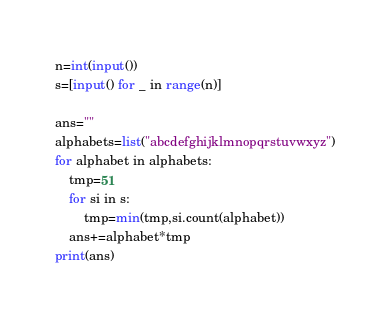<code> <loc_0><loc_0><loc_500><loc_500><_Python_>n=int(input())
s=[input() for _ in range(n)]

ans=""
alphabets=list("abcdefghijklmnopqrstuvwxyz")
for alphabet in alphabets:
    tmp=51
    for si in s:
        tmp=min(tmp,si.count(alphabet))
    ans+=alphabet*tmp
print(ans)</code> 